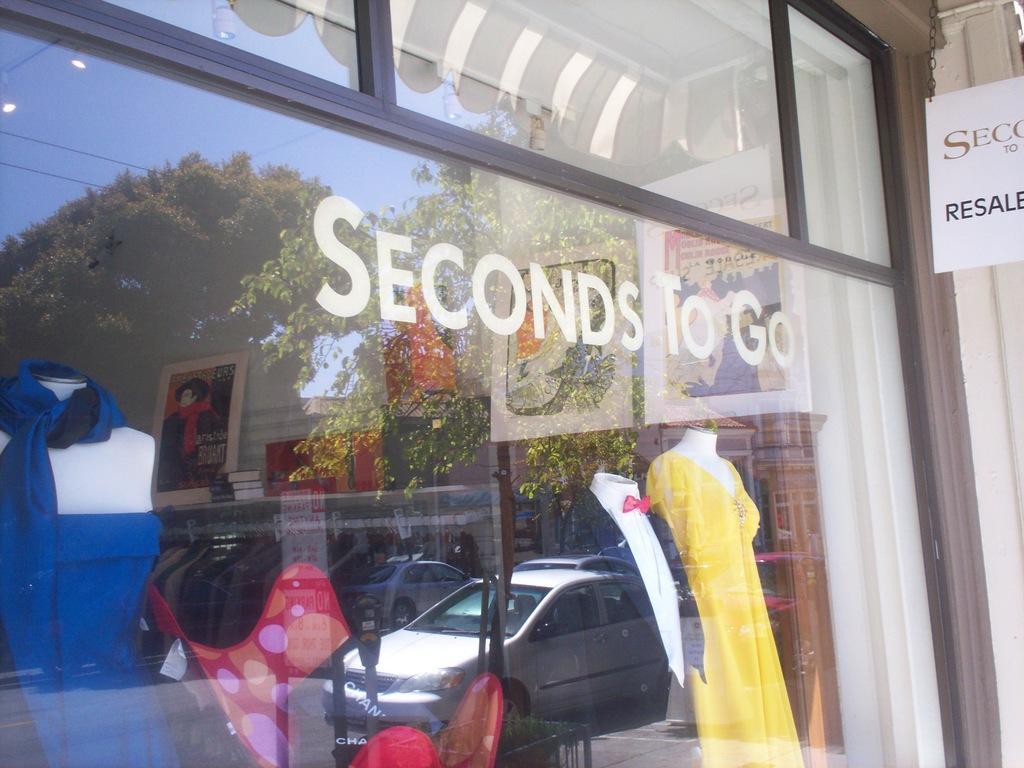How would you summarize this image in a sentence or two? In the image there is a store front with mannequins behind the glass and car reflection on the glass with some text and a board on it. 